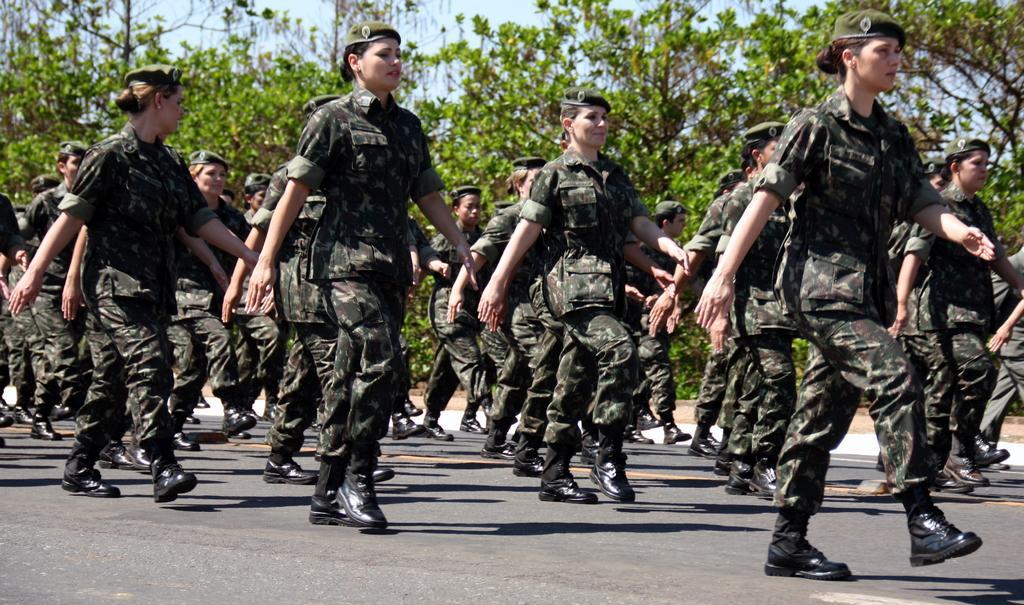In one or two sentences, can you explain what this image depicts? In this picture there are group of people marching on the road. At the back there are trees. At the top there is sky. At the bottom there is a road and there is ground. 